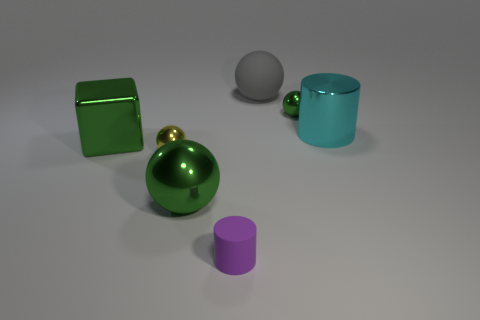Are there more metal balls that are to the left of the big green ball than small gray rubber things?
Your answer should be very brief. Yes. Is there a large blue cube?
Ensure brevity in your answer.  No. Is the color of the rubber ball the same as the small cylinder?
Offer a very short reply. No. What number of big things are gray shiny cylinders or green metallic things?
Your answer should be very brief. 2. Are there any other things of the same color as the metal cylinder?
Make the answer very short. No. There is another tiny object that is made of the same material as the small yellow thing; what shape is it?
Make the answer very short. Sphere. There is a metal ball that is in front of the tiny yellow sphere; what size is it?
Your answer should be compact. Large. What shape is the yellow object?
Your answer should be compact. Sphere. There is a cylinder that is on the right side of the small matte cylinder; is its size the same as the green shiny thing in front of the shiny cube?
Your response must be concise. Yes. There is a cylinder left of the small metallic ball behind the big thing that is on the right side of the large rubber thing; how big is it?
Provide a succinct answer. Small. 